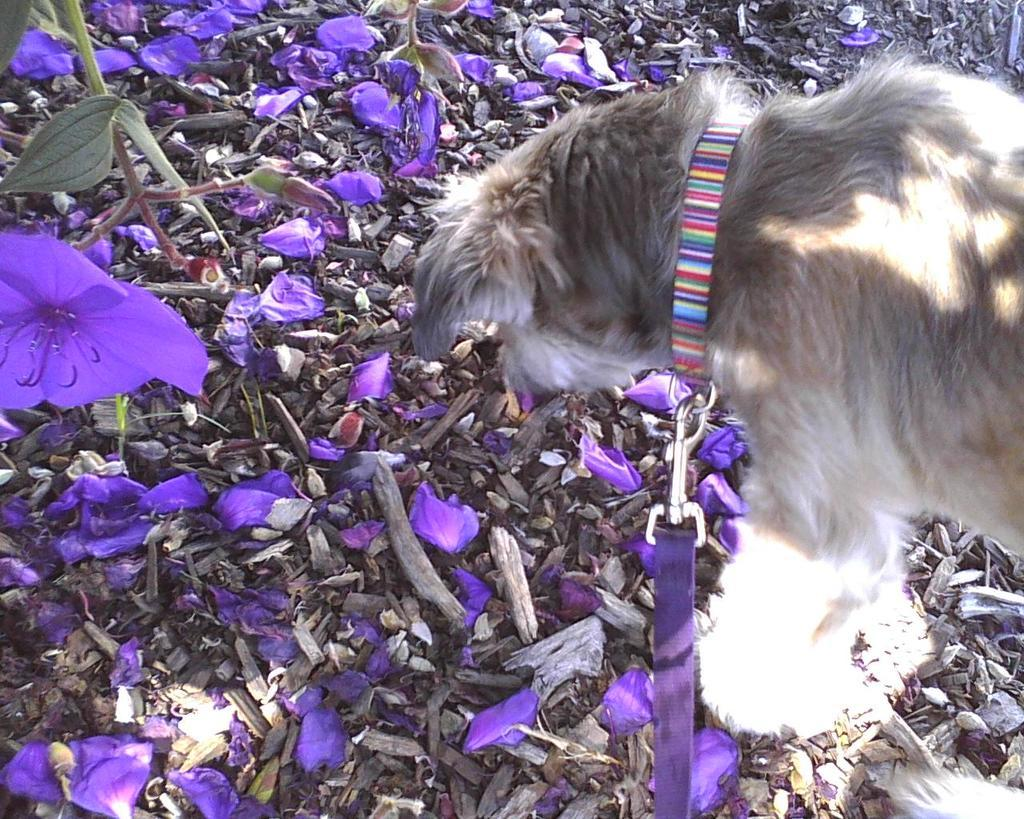What type of animal is on the right side of the image? There is a dog on the right side of the image. What can be seen on the left side of the image? There are flowers on the left side of the image. Are there any flowers visible on the ground in the image? Yes, there are flowers on the ground in the image. What else can be found on the ground in the image? There are other objects on the ground in the image. What is the texture of the dog's muscles in the image? There is no information about the dog's muscles or texture in the image. 